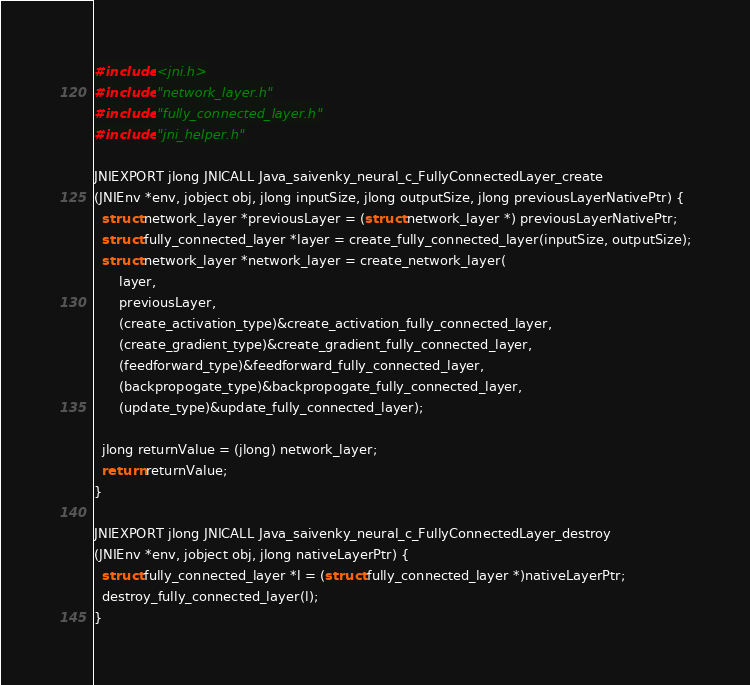Convert code to text. <code><loc_0><loc_0><loc_500><loc_500><_C_>#include <jni.h>
#include "network_layer.h"
#include "fully_connected_layer.h"
#include "jni_helper.h"

JNIEXPORT jlong JNICALL Java_saivenky_neural_c_FullyConnectedLayer_create
(JNIEnv *env, jobject obj, jlong inputSize, jlong outputSize, jlong previousLayerNativePtr) {
  struct network_layer *previousLayer = (struct network_layer *) previousLayerNativePtr;
  struct fully_connected_layer *layer = create_fully_connected_layer(inputSize, outputSize);
  struct network_layer *network_layer = create_network_layer(
      layer,
      previousLayer,
      (create_activation_type)&create_activation_fully_connected_layer,
      (create_gradient_type)&create_gradient_fully_connected_layer,
      (feedforward_type)&feedforward_fully_connected_layer,
      (backpropogate_type)&backpropogate_fully_connected_layer,
      (update_type)&update_fully_connected_layer);

  jlong returnValue = (jlong) network_layer;
  return returnValue;
}

JNIEXPORT jlong JNICALL Java_saivenky_neural_c_FullyConnectedLayer_destroy
(JNIEnv *env, jobject obj, jlong nativeLayerPtr) {
  struct fully_connected_layer *l = (struct fully_connected_layer *)nativeLayerPtr;
  destroy_fully_connected_layer(l);
}
</code> 